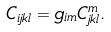<formula> <loc_0><loc_0><loc_500><loc_500>C _ { i j k l } = g _ { i m } C ^ { m } _ { j k l } .</formula> 